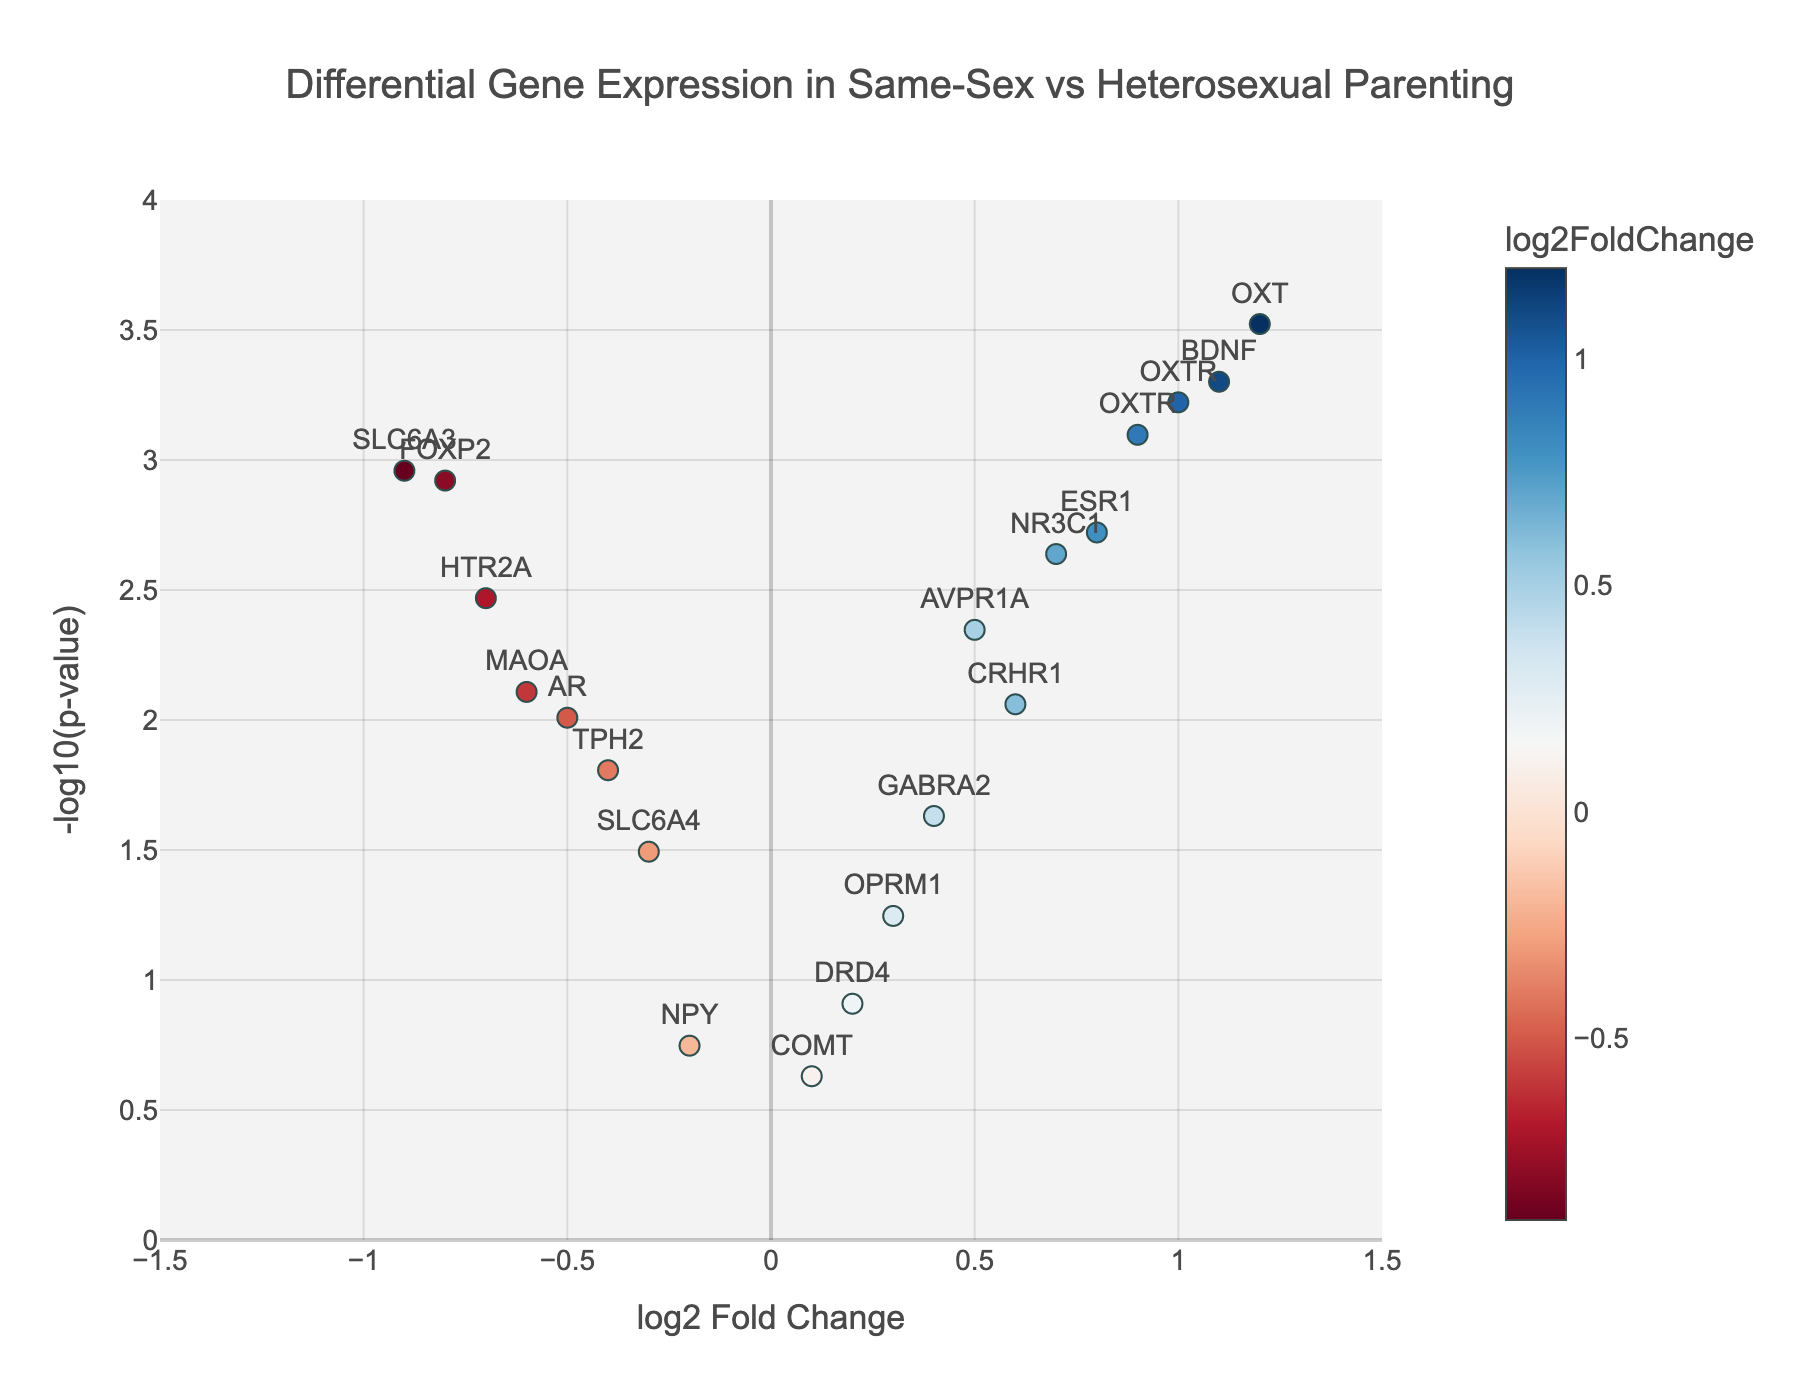What is the title of the figure? The title of the figure is written at the top center of the plot. It reads "Differential Gene Expression in Same-Sex vs Heterosexual Parenting".
Answer: Differential Gene Expression in Same-Sex vs Heterosexual Parenting Which gene has the highest log2FoldChange? By looking at the x-axis, the gene with the highest log2FoldChange is the one furthest to the right. This gene is OXT with a log2FoldChange of 1.2.
Answer: OXT What does the y-axis represent? The y-axis represents the -log10 of the p-value, which measures the statistical significance of the change in gene expression.
Answer: -log10(p-value) How many genes have a p-value less than 0.01? To determine this, we look at the y-axis values above 2 (since -log10(0.01) = 2) and count the corresponding points. There are 9 genes with -log10(p-value) greater than 2.
Answer: 9 Which gene shows the greatest decrease in expression? The gene with the lowest log2FoldChange (farthest left on the x-axis) shows the greatest decrease. It is SLC6A3 with a log2FoldChange of -0.9.
Answer: SLC6A3 Compare the expression changes for the genes FOXP2 and AR. Which one has a more statistically significant expression change? To compare the statistical significance, we look at the y-axis, -log10(p-value), for both genes. FOXP2 has a higher value at 2.92 compared to AR's value of 2.01, making FOXP2's change more significant.
Answer: FOXP2 What's the range of -log10(p-value) for the plotted genes? The highest value on the y-axis is around 3.52 and the lowest close to 0, giving a range from approximately 0 to 3.52.
Answer: 0 to 3.52 Which gene has a log2FoldChange of 0.6 and what is its p-value? By identifying the gene positioned at log2FoldChange 0.6, one can find that it is CRHR1. Its p-value, corresponding to the y-position, converts to a -log10(p-value) of approximately 2.06, giving a p-value around 0.0087.
Answer: CRHR1, 0.0087 What is the dominant color on the left side of the plot? The dominant color on the left side represents negative log2FoldChange values, which are in shades of blue.
Answer: Blue Are any two genes equally expressed according to log2FoldChange? Yes, the gene OXTR appears twice with log2FoldChanges of 0.9 and 1.0 respectively, showing similar but not equal expressions.
Answer: No equal expressions 